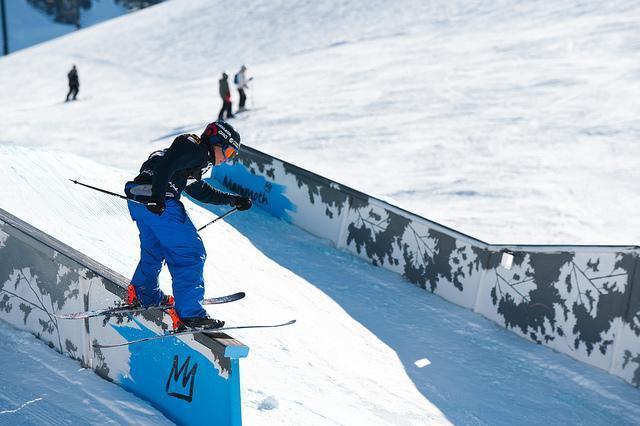How many people are on the rail?
Give a very brief answer. 1. 